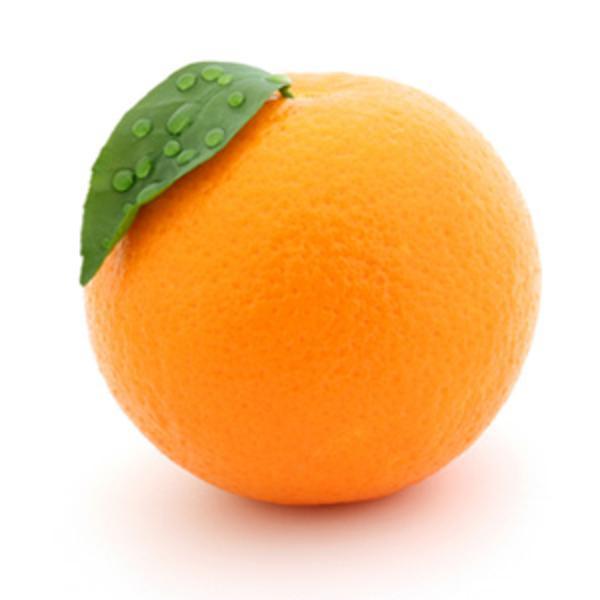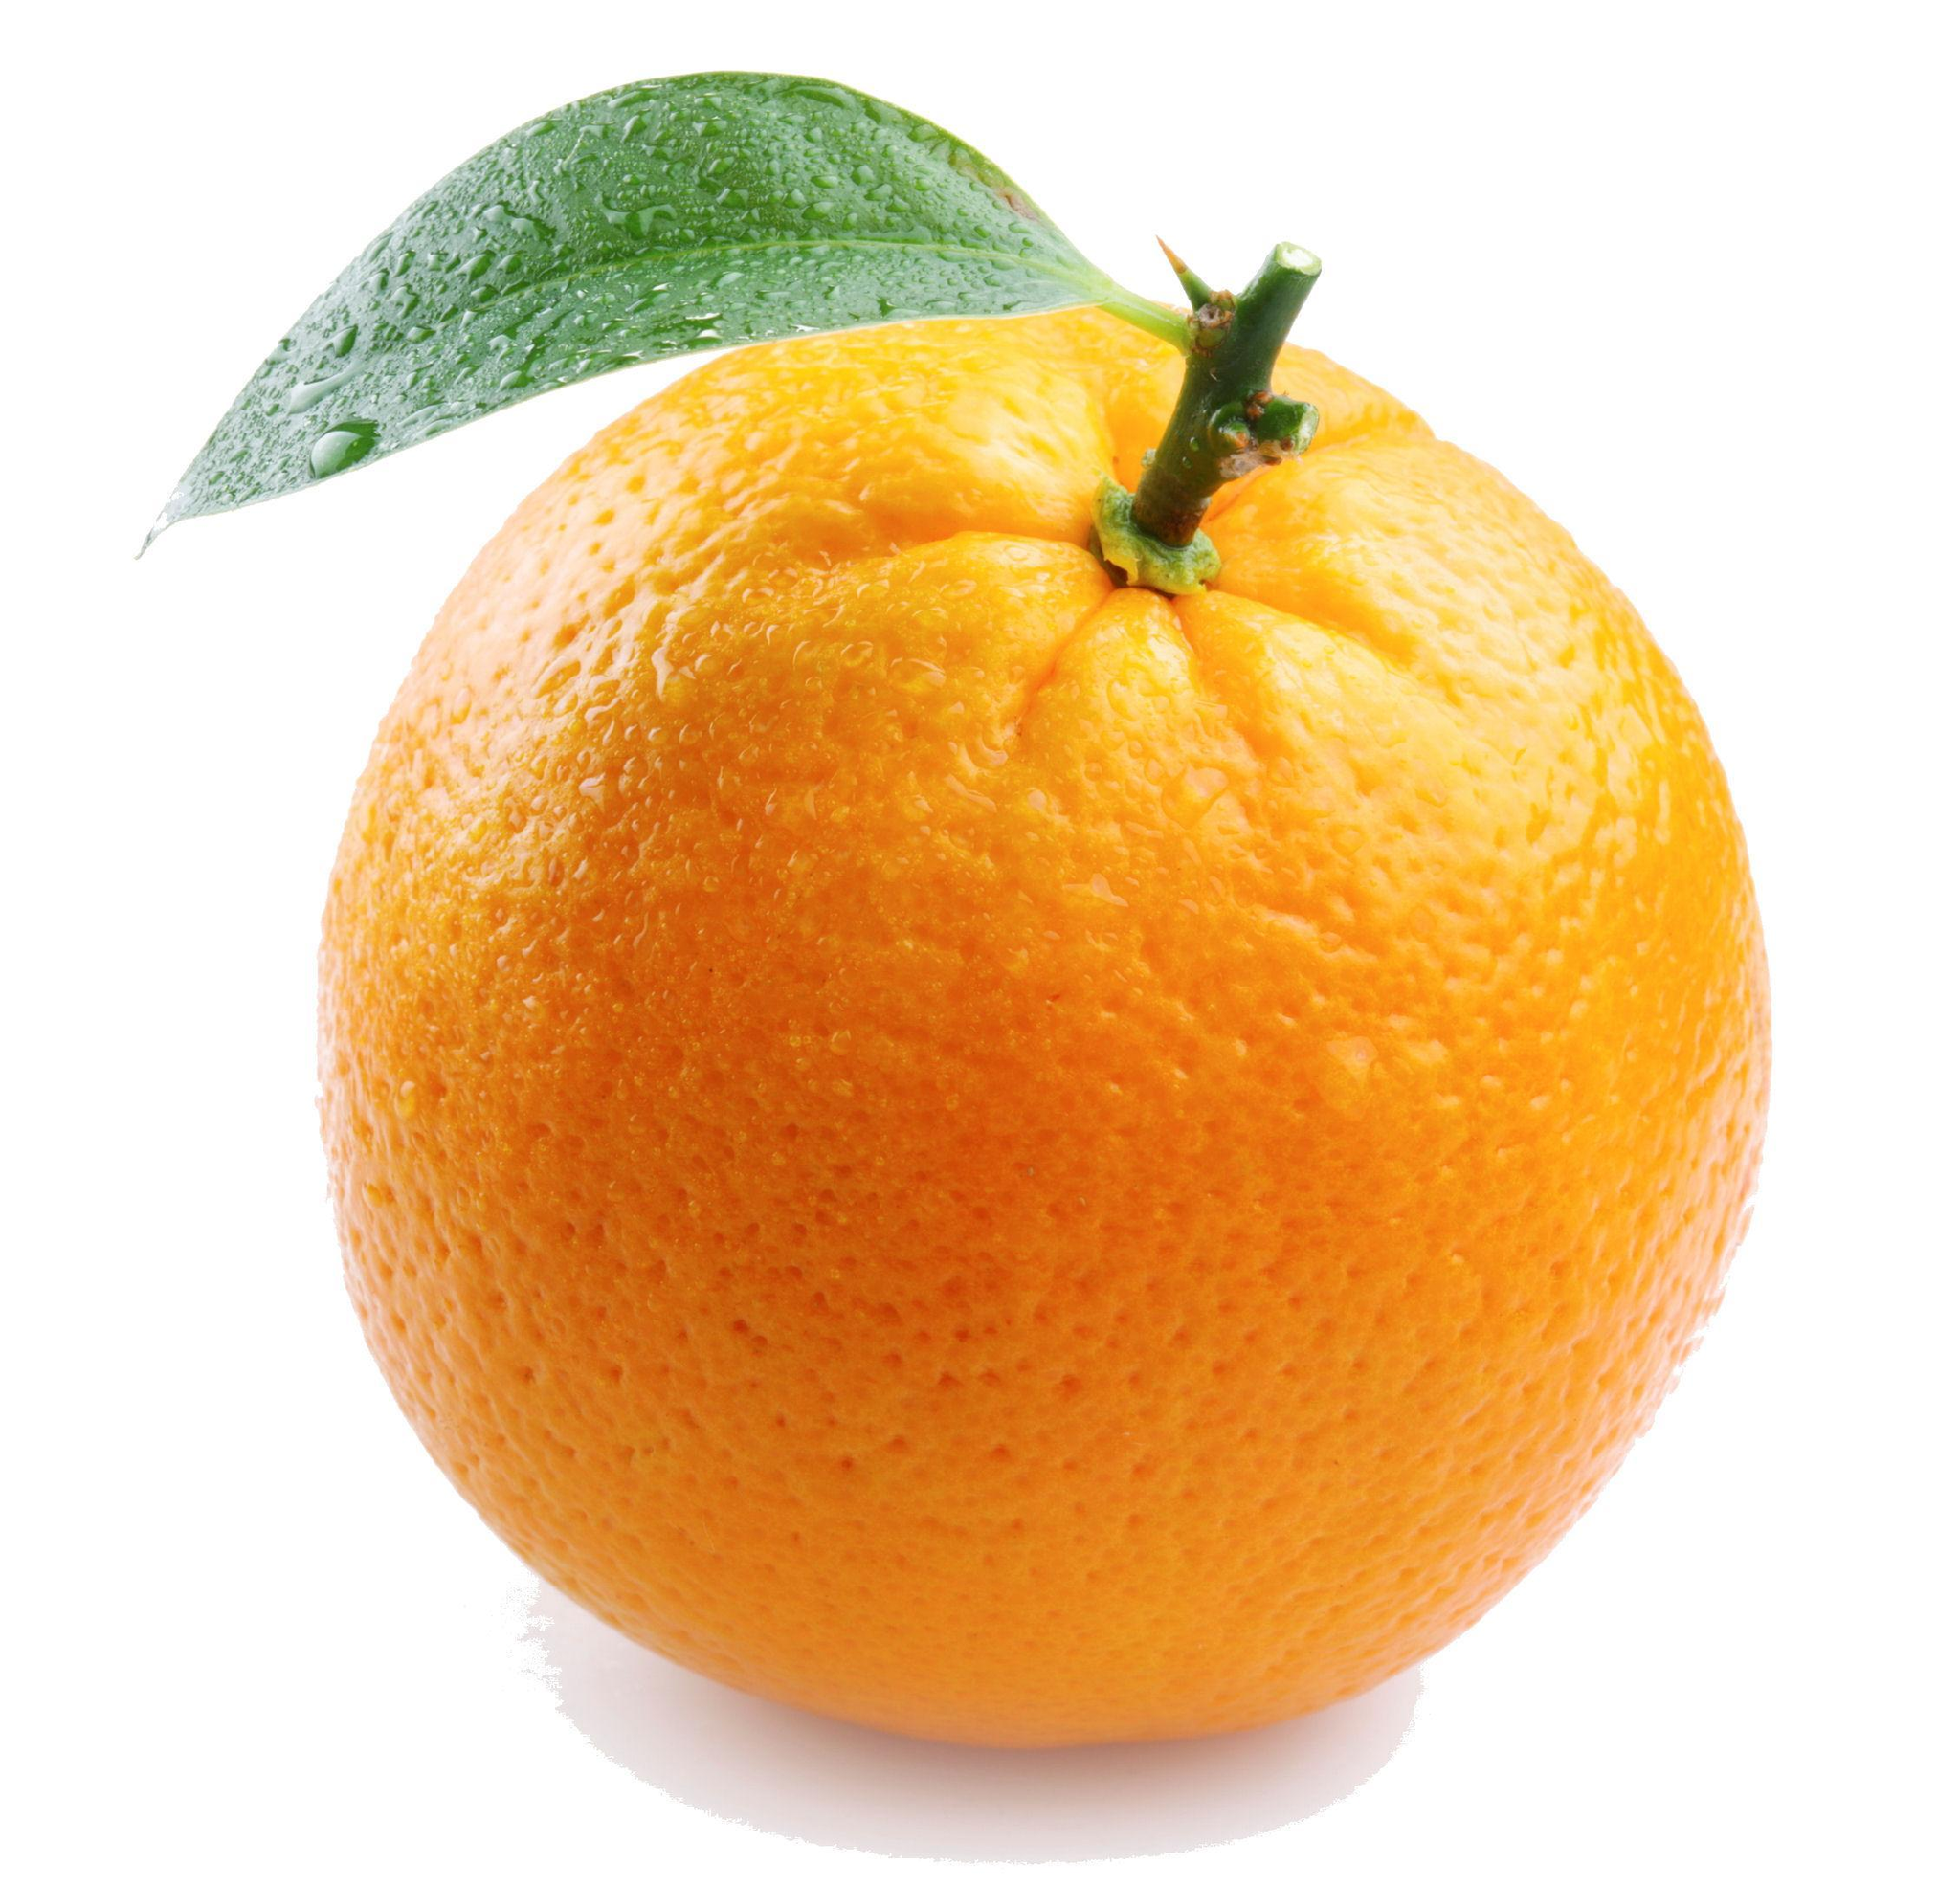The first image is the image on the left, the second image is the image on the right. For the images displayed, is the sentence "There is at least one half of an orange along with other oranges." factually correct? Answer yes or no. No. The first image is the image on the left, the second image is the image on the right. Examine the images to the left and right. Is the description "An orange has been sliced into halves" accurate? Answer yes or no. No. 